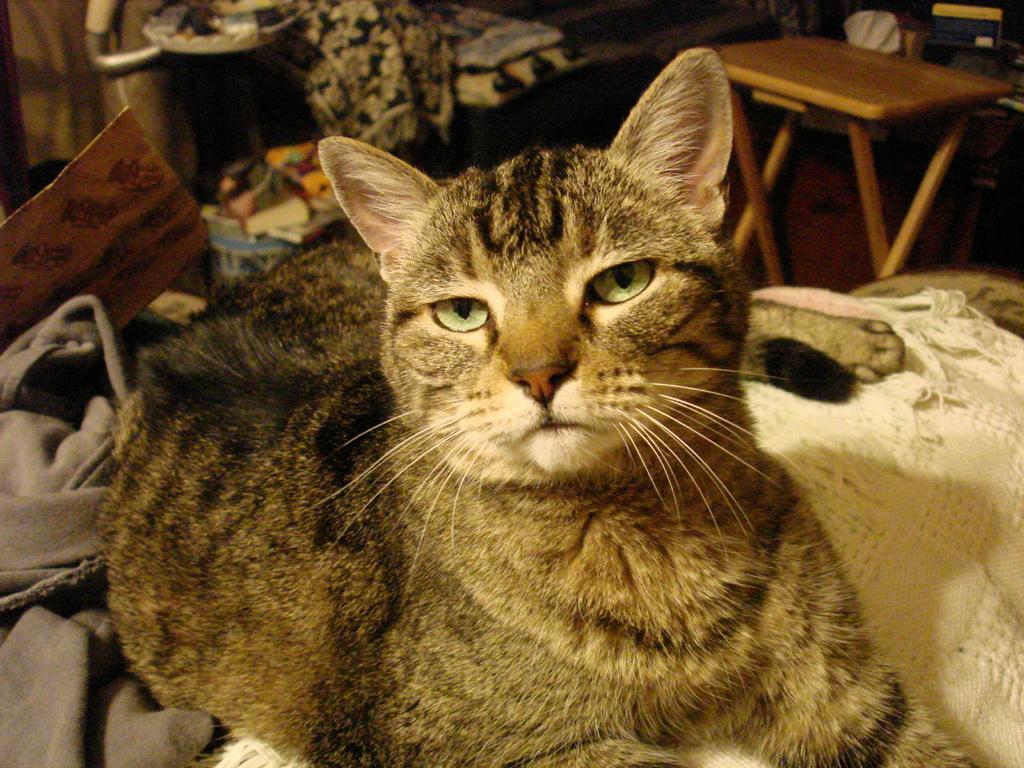Describe this image in one or two sentences. there is a cat, behind her there is a table. 